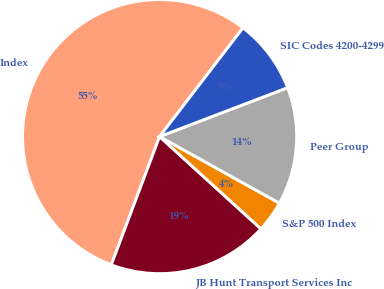Convert chart. <chart><loc_0><loc_0><loc_500><loc_500><pie_chart><fcel>Index<fcel>JB Hunt Transport Services Inc<fcel>S&P 500 Index<fcel>Peer Group<fcel>SIC Codes 4200-4299<nl><fcel>54.68%<fcel>18.98%<fcel>3.68%<fcel>13.88%<fcel>8.78%<nl></chart> 